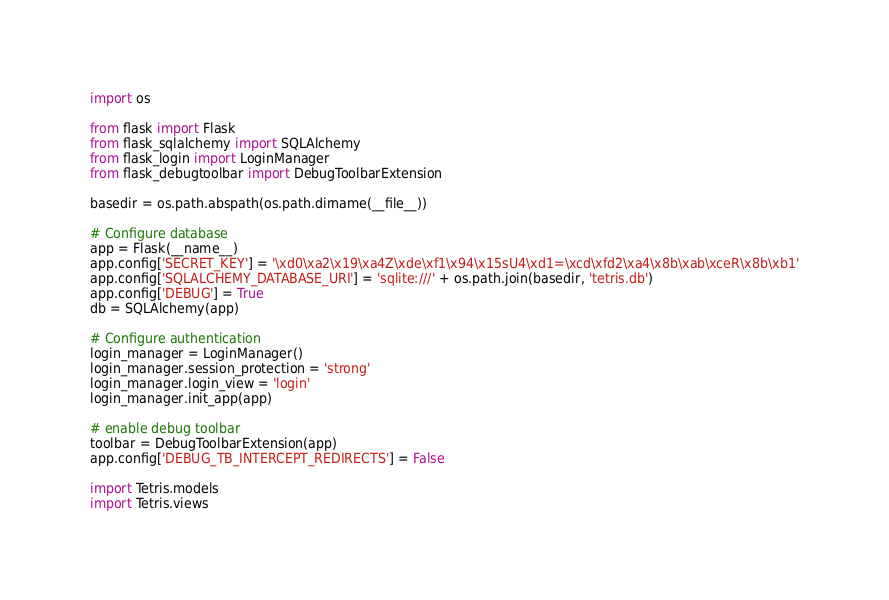<code> <loc_0><loc_0><loc_500><loc_500><_Python_>import os

from flask import Flask
from flask_sqlalchemy import SQLAlchemy
from flask_login import LoginManager
from flask_debugtoolbar import DebugToolbarExtension

basedir = os.path.abspath(os.path.dirname(__file__))

# Configure database
app = Flask(__name__)
app.config['SECRET_KEY'] = '\xd0\xa2\x19\xa4Z\xde\xf1\x94\x15sU4\xd1=\xcd\xfd2\xa4\x8b\xab\xceR\x8b\xb1'
app.config['SQLALCHEMY_DATABASE_URI'] = 'sqlite:///' + os.path.join(basedir, 'tetris.db')
app.config['DEBUG'] = True
db = SQLAlchemy(app)

# Configure authentication
login_manager = LoginManager()
login_manager.session_protection = 'strong'
login_manager.login_view = 'login'
login_manager.init_app(app)

# enable debug toolbar
toolbar = DebugToolbarExtension(app)
app.config['DEBUG_TB_INTERCEPT_REDIRECTS'] = False

import Tetris.models
import Tetris.views
</code> 